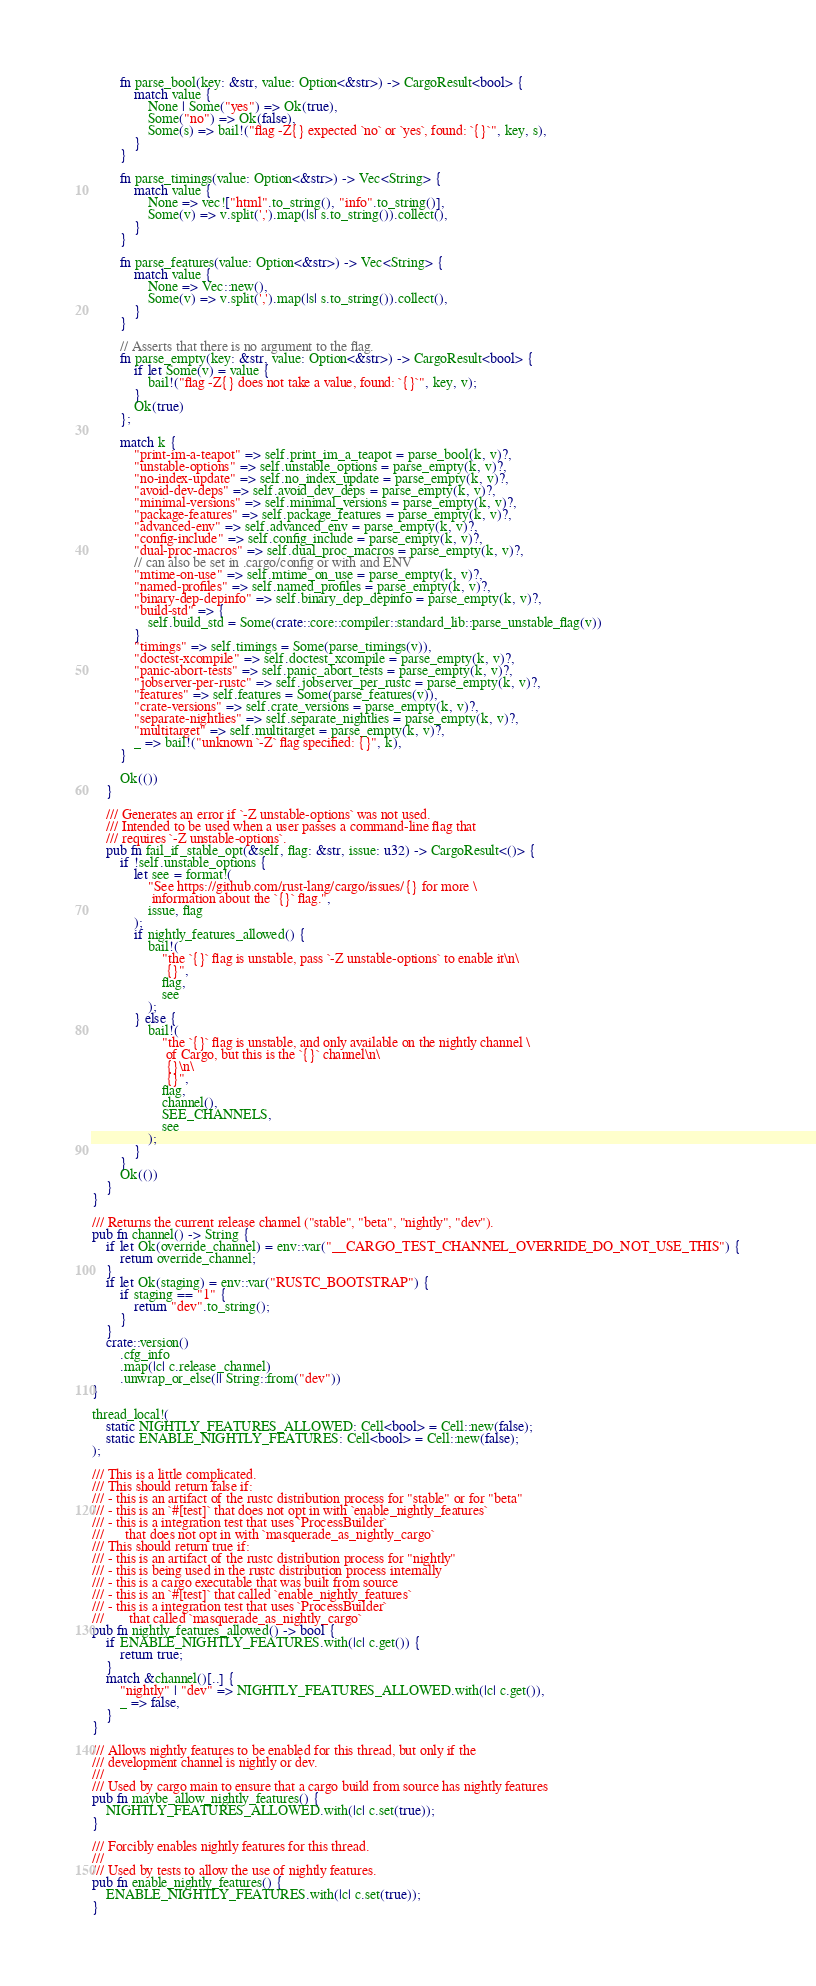Convert code to text. <code><loc_0><loc_0><loc_500><loc_500><_Rust_>        fn parse_bool(key: &str, value: Option<&str>) -> CargoResult<bool> {
            match value {
                None | Some("yes") => Ok(true),
                Some("no") => Ok(false),
                Some(s) => bail!("flag -Z{} expected `no` or `yes`, found: `{}`", key, s),
            }
        }

        fn parse_timings(value: Option<&str>) -> Vec<String> {
            match value {
                None => vec!["html".to_string(), "info".to_string()],
                Some(v) => v.split(',').map(|s| s.to_string()).collect(),
            }
        }

        fn parse_features(value: Option<&str>) -> Vec<String> {
            match value {
                None => Vec::new(),
                Some(v) => v.split(',').map(|s| s.to_string()).collect(),
            }
        }

        // Asserts that there is no argument to the flag.
        fn parse_empty(key: &str, value: Option<&str>) -> CargoResult<bool> {
            if let Some(v) = value {
                bail!("flag -Z{} does not take a value, found: `{}`", key, v);
            }
            Ok(true)
        };

        match k {
            "print-im-a-teapot" => self.print_im_a_teapot = parse_bool(k, v)?,
            "unstable-options" => self.unstable_options = parse_empty(k, v)?,
            "no-index-update" => self.no_index_update = parse_empty(k, v)?,
            "avoid-dev-deps" => self.avoid_dev_deps = parse_empty(k, v)?,
            "minimal-versions" => self.minimal_versions = parse_empty(k, v)?,
            "package-features" => self.package_features = parse_empty(k, v)?,
            "advanced-env" => self.advanced_env = parse_empty(k, v)?,
            "config-include" => self.config_include = parse_empty(k, v)?,
            "dual-proc-macros" => self.dual_proc_macros = parse_empty(k, v)?,
            // can also be set in .cargo/config or with and ENV
            "mtime-on-use" => self.mtime_on_use = parse_empty(k, v)?,
            "named-profiles" => self.named_profiles = parse_empty(k, v)?,
            "binary-dep-depinfo" => self.binary_dep_depinfo = parse_empty(k, v)?,
            "build-std" => {
                self.build_std = Some(crate::core::compiler::standard_lib::parse_unstable_flag(v))
            }
            "timings" => self.timings = Some(parse_timings(v)),
            "doctest-xcompile" => self.doctest_xcompile = parse_empty(k, v)?,
            "panic-abort-tests" => self.panic_abort_tests = parse_empty(k, v)?,
            "jobserver-per-rustc" => self.jobserver_per_rustc = parse_empty(k, v)?,
            "features" => self.features = Some(parse_features(v)),
            "crate-versions" => self.crate_versions = parse_empty(k, v)?,
            "separate-nightlies" => self.separate_nightlies = parse_empty(k, v)?,
            "multitarget" => self.multitarget = parse_empty(k, v)?,
            _ => bail!("unknown `-Z` flag specified: {}", k),
        }

        Ok(())
    }

    /// Generates an error if `-Z unstable-options` was not used.
    /// Intended to be used when a user passes a command-line flag that
    /// requires `-Z unstable-options`.
    pub fn fail_if_stable_opt(&self, flag: &str, issue: u32) -> CargoResult<()> {
        if !self.unstable_options {
            let see = format!(
                "See https://github.com/rust-lang/cargo/issues/{} for more \
                 information about the `{}` flag.",
                issue, flag
            );
            if nightly_features_allowed() {
                bail!(
                    "the `{}` flag is unstable, pass `-Z unstable-options` to enable it\n\
                     {}",
                    flag,
                    see
                );
            } else {
                bail!(
                    "the `{}` flag is unstable, and only available on the nightly channel \
                     of Cargo, but this is the `{}` channel\n\
                     {}\n\
                     {}",
                    flag,
                    channel(),
                    SEE_CHANNELS,
                    see
                );
            }
        }
        Ok(())
    }
}

/// Returns the current release channel ("stable", "beta", "nightly", "dev").
pub fn channel() -> String {
    if let Ok(override_channel) = env::var("__CARGO_TEST_CHANNEL_OVERRIDE_DO_NOT_USE_THIS") {
        return override_channel;
    }
    if let Ok(staging) = env::var("RUSTC_BOOTSTRAP") {
        if staging == "1" {
            return "dev".to_string();
        }
    }
    crate::version()
        .cfg_info
        .map(|c| c.release_channel)
        .unwrap_or_else(|| String::from("dev"))
}

thread_local!(
    static NIGHTLY_FEATURES_ALLOWED: Cell<bool> = Cell::new(false);
    static ENABLE_NIGHTLY_FEATURES: Cell<bool> = Cell::new(false);
);

/// This is a little complicated.
/// This should return false if:
/// - this is an artifact of the rustc distribution process for "stable" or for "beta"
/// - this is an `#[test]` that does not opt in with `enable_nightly_features`
/// - this is a integration test that uses `ProcessBuilder`
///      that does not opt in with `masquerade_as_nightly_cargo`
/// This should return true if:
/// - this is an artifact of the rustc distribution process for "nightly"
/// - this is being used in the rustc distribution process internally
/// - this is a cargo executable that was built from source
/// - this is an `#[test]` that called `enable_nightly_features`
/// - this is a integration test that uses `ProcessBuilder`
///       that called `masquerade_as_nightly_cargo`
pub fn nightly_features_allowed() -> bool {
    if ENABLE_NIGHTLY_FEATURES.with(|c| c.get()) {
        return true;
    }
    match &channel()[..] {
        "nightly" | "dev" => NIGHTLY_FEATURES_ALLOWED.with(|c| c.get()),
        _ => false,
    }
}

/// Allows nightly features to be enabled for this thread, but only if the
/// development channel is nightly or dev.
///
/// Used by cargo main to ensure that a cargo build from source has nightly features
pub fn maybe_allow_nightly_features() {
    NIGHTLY_FEATURES_ALLOWED.with(|c| c.set(true));
}

/// Forcibly enables nightly features for this thread.
///
/// Used by tests to allow the use of nightly features.
pub fn enable_nightly_features() {
    ENABLE_NIGHTLY_FEATURES.with(|c| c.set(true));
}
</code> 